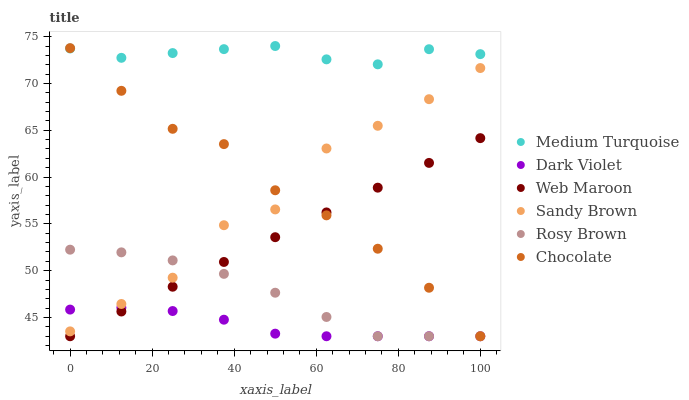Does Dark Violet have the minimum area under the curve?
Answer yes or no. Yes. Does Medium Turquoise have the maximum area under the curve?
Answer yes or no. Yes. Does Web Maroon have the minimum area under the curve?
Answer yes or no. No. Does Web Maroon have the maximum area under the curve?
Answer yes or no. No. Is Web Maroon the smoothest?
Answer yes or no. Yes. Is Sandy Brown the roughest?
Answer yes or no. Yes. Is Dark Violet the smoothest?
Answer yes or no. No. Is Dark Violet the roughest?
Answer yes or no. No. Does Rosy Brown have the lowest value?
Answer yes or no. Yes. Does Medium Turquoise have the lowest value?
Answer yes or no. No. Does Medium Turquoise have the highest value?
Answer yes or no. Yes. Does Web Maroon have the highest value?
Answer yes or no. No. Is Web Maroon less than Medium Turquoise?
Answer yes or no. Yes. Is Medium Turquoise greater than Dark Violet?
Answer yes or no. Yes. Does Dark Violet intersect Chocolate?
Answer yes or no. Yes. Is Dark Violet less than Chocolate?
Answer yes or no. No. Is Dark Violet greater than Chocolate?
Answer yes or no. No. Does Web Maroon intersect Medium Turquoise?
Answer yes or no. No. 